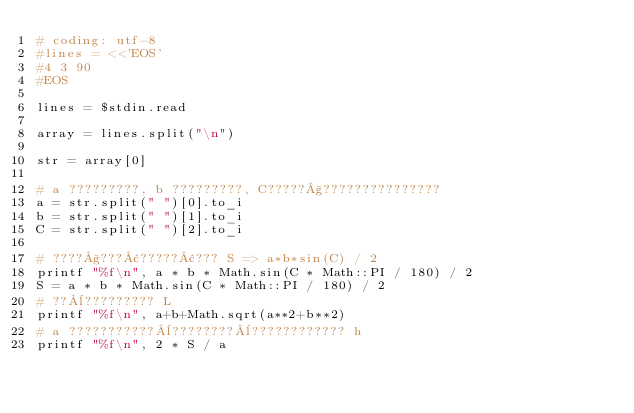<code> <loc_0><loc_0><loc_500><loc_500><_Ruby_># coding: utf-8
#lines = <<'EOS'
#4 3 90
#EOS

lines = $stdin.read

array = lines.split("\n")

str = array[0]

# a ?????????, b ?????????, C?????§???????????????
a = str.split(" ")[0].to_i
b = str.split(" ")[1].to_i
C = str.split(" ")[2].to_i

# ????§???¢?????¢??? S => a*b*sin(C) / 2
printf "%f\n", a * b * Math.sin(C * Math::PI / 180) / 2
S = a * b * Math.sin(C * Math::PI / 180) / 2
# ??¨????????? L
printf "%f\n", a+b+Math.sqrt(a**2+b**2)
# a ???????????¨????????¨???????????? h
printf "%f\n", 2 * S / a</code> 